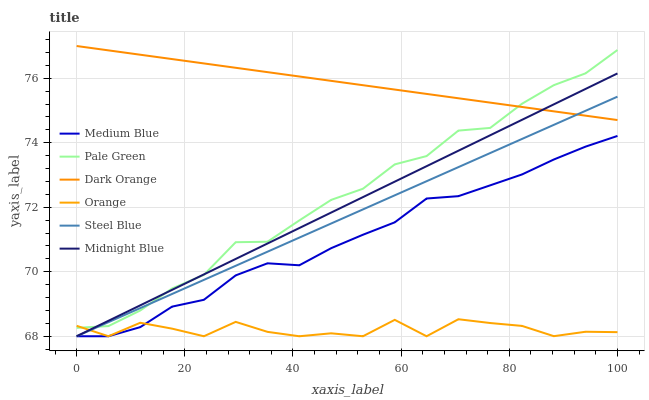Does Orange have the minimum area under the curve?
Answer yes or no. Yes. Does Dark Orange have the maximum area under the curve?
Answer yes or no. Yes. Does Midnight Blue have the minimum area under the curve?
Answer yes or no. No. Does Midnight Blue have the maximum area under the curve?
Answer yes or no. No. Is Steel Blue the smoothest?
Answer yes or no. Yes. Is Orange the roughest?
Answer yes or no. Yes. Is Midnight Blue the smoothest?
Answer yes or no. No. Is Midnight Blue the roughest?
Answer yes or no. No. Does Pale Green have the lowest value?
Answer yes or no. No. Does Dark Orange have the highest value?
Answer yes or no. Yes. Does Midnight Blue have the highest value?
Answer yes or no. No. Is Orange less than Dark Orange?
Answer yes or no. Yes. Is Dark Orange greater than Orange?
Answer yes or no. Yes. Does Orange intersect Dark Orange?
Answer yes or no. No. 